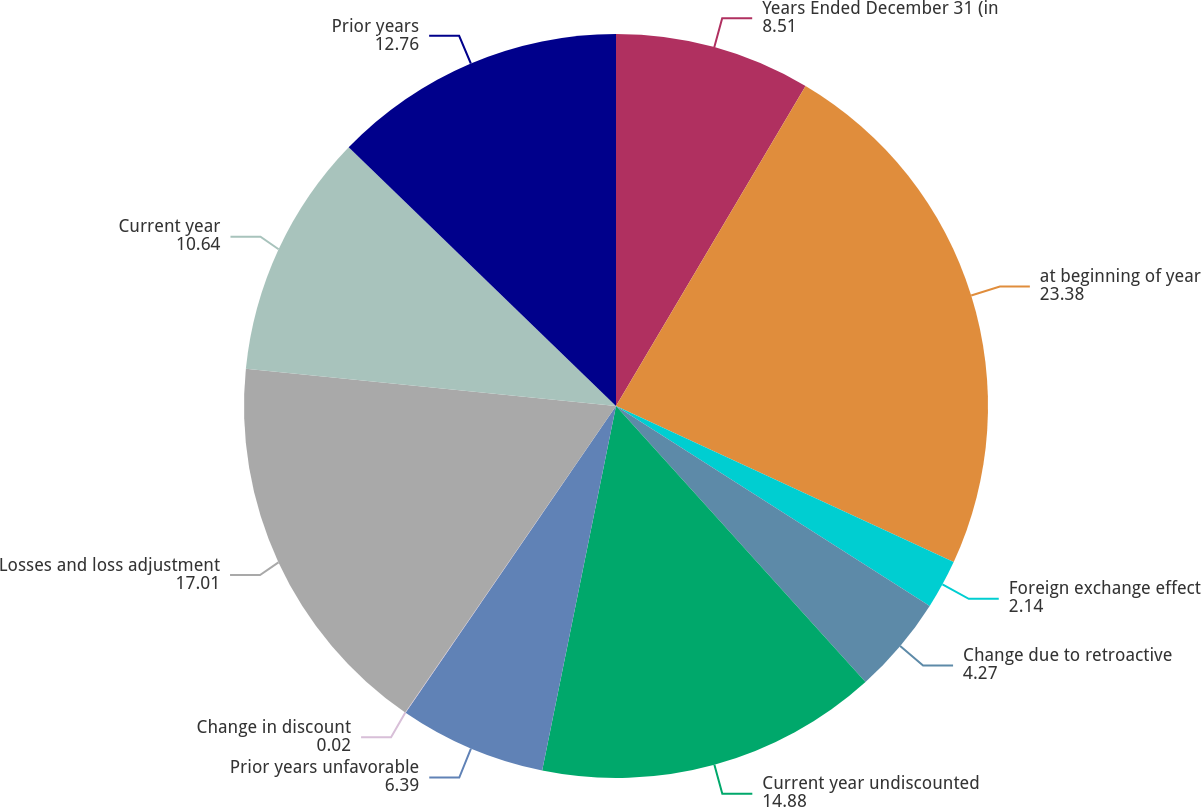Convert chart to OTSL. <chart><loc_0><loc_0><loc_500><loc_500><pie_chart><fcel>Years Ended December 31 (in<fcel>at beginning of year<fcel>Foreign exchange effect<fcel>Change due to retroactive<fcel>Current year undiscounted<fcel>Prior years unfavorable<fcel>Change in discount<fcel>Losses and loss adjustment<fcel>Current year<fcel>Prior years<nl><fcel>8.51%<fcel>23.38%<fcel>2.14%<fcel>4.27%<fcel>14.88%<fcel>6.39%<fcel>0.02%<fcel>17.01%<fcel>10.64%<fcel>12.76%<nl></chart> 